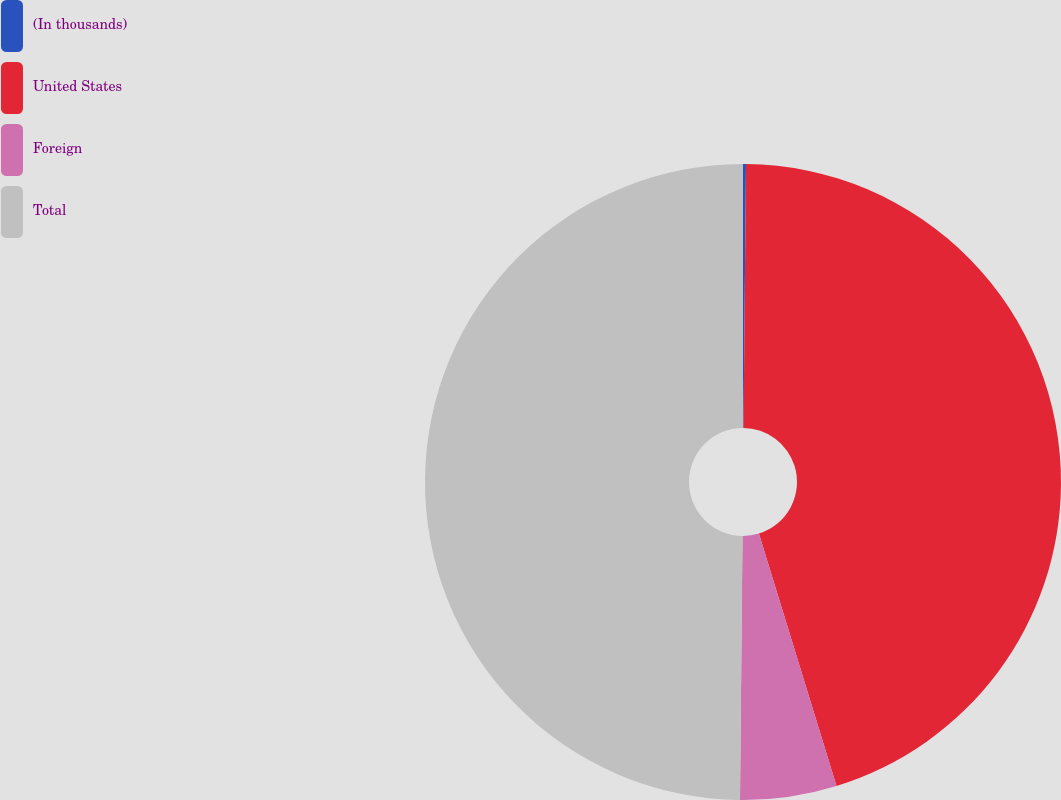Convert chart. <chart><loc_0><loc_0><loc_500><loc_500><pie_chart><fcel>(In thousands)<fcel>United States<fcel>Foreign<fcel>Total<nl><fcel>0.15%<fcel>45.1%<fcel>4.9%<fcel>49.85%<nl></chart> 